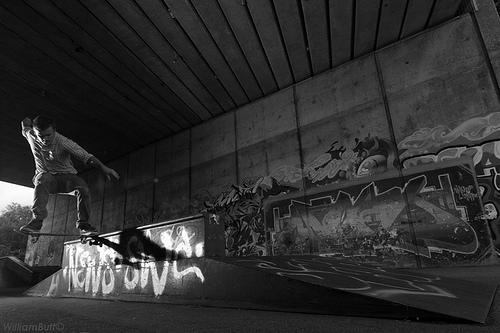How many people are there?
Give a very brief answer. 1. How many people are in the picture?
Give a very brief answer. 1. 